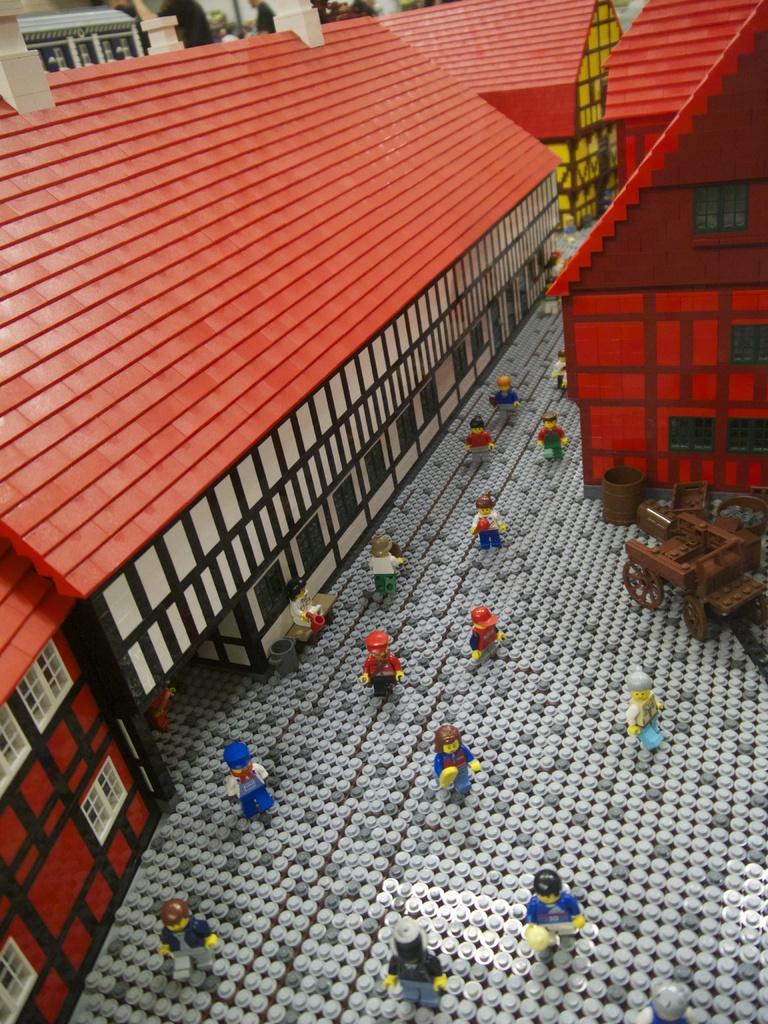In one or two sentences, can you explain what this image depicts? In this image, I can see a LEGO puzzle of buildings, people, wheel cart and few other objects. 